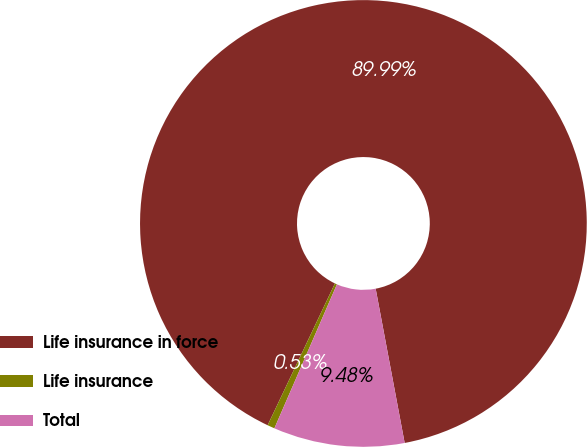Convert chart to OTSL. <chart><loc_0><loc_0><loc_500><loc_500><pie_chart><fcel>Life insurance in force<fcel>Life insurance<fcel>Total<nl><fcel>89.99%<fcel>0.53%<fcel>9.48%<nl></chart> 